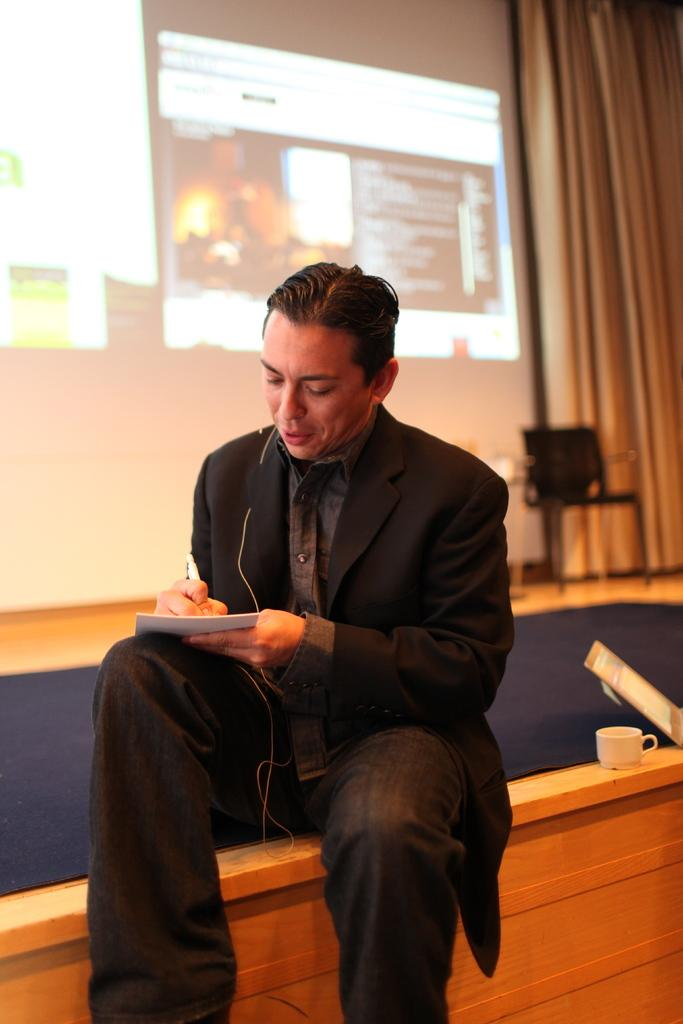What is the person in the image doing? The person is sitting and writing on a paper. What is located behind the person in the image? There is a projector screen behind the person. What beverage might the person be consuming, based on the presence of the coffee cup? The person might be drinking coffee, as there is a coffee cup present in the image. What material is the object on which the coffee cup is placed? The coffee cup is placed on a wooden object. What type of owl can be seen perched on the projector screen in the image? There is no owl present in the image; it only features a person sitting and writing, a projector screen, a coffee cup, and a wooden object. 